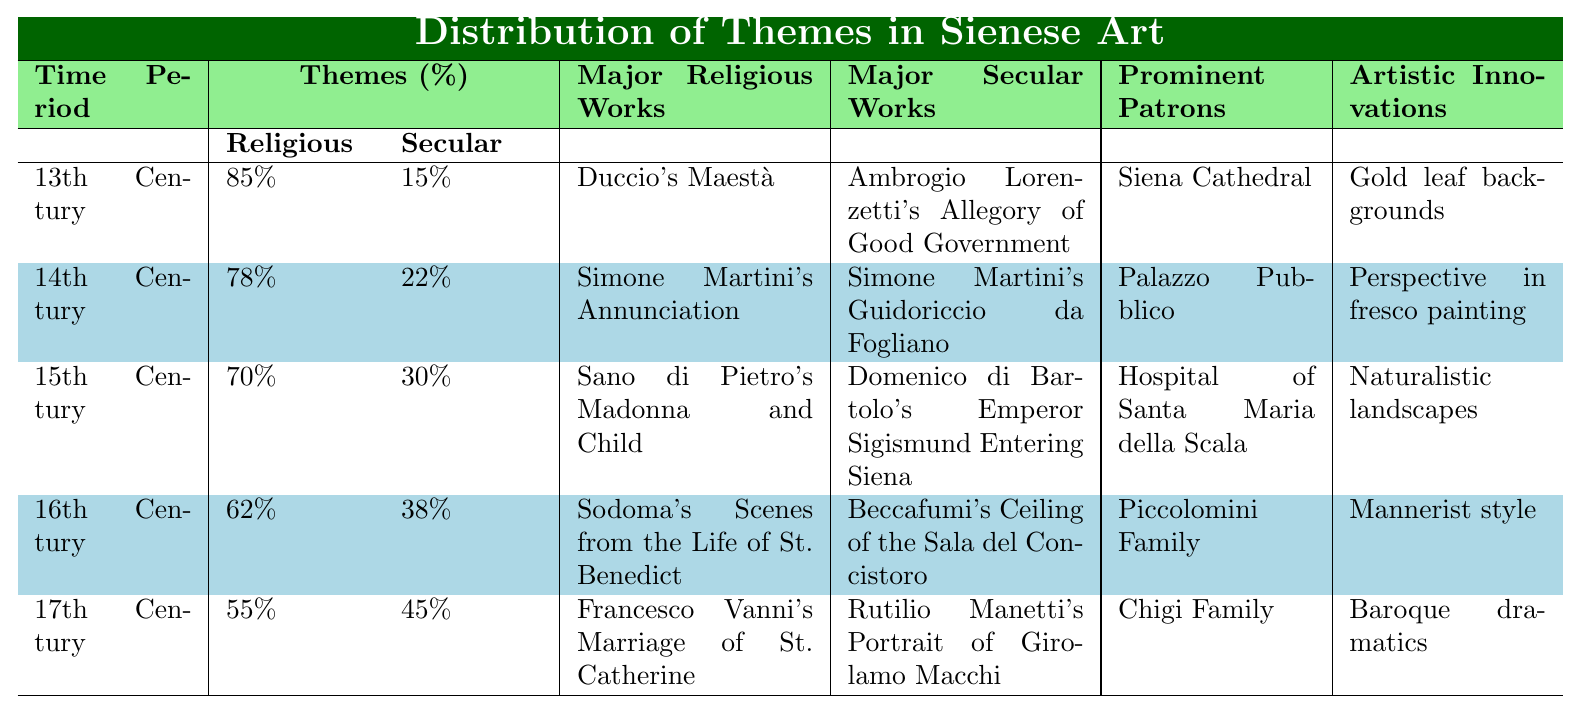What was the percentage of religious themes in the 16th century? The 16th century has a percentage of religious themes listed as 62% in the table.
Answer: 62% Which time period had the highest percentage of secular themes? Upon examining the table, the 17th century shows the highest secular themes percentage at 45%.
Answer: 17th century What major religious work is associated with the 14th century? According to the table, Simone Martini's Annunciation is the major religious work for the 14th century.
Answer: Simone Martini's Annunciation What is the difference in percentage of religious themes between the 13th and 15th centuries? The 13th century has 85% religious themes, and the 15th has 70%. The difference is 85% - 70% = 15%.
Answer: 15% True or False: The percentage of secular themes increased in each subsequent century from the 13th to the 17th century. By reviewing the table, the secular theme percentages are 15%, 22%, 30%, 38%, and 45%, respectively, showing a consistent increase.
Answer: True In which century do we first see less than 60% of religious themes? Looking at the data, the 17th century is the first where religious themes drop below 60%, at 55%.
Answer: 17th century What was the trend in religious themes from the 13th to the 17th century? The trend shows a clear decrease in religious themes: 85% (13th), 78% (14th), 70% (15th), 62% (16th), to 55% (17th), signaling a decline.
Answer: Decrease Which family was a prominent patron during the 17th century? The table indicates that the Chigi Family was the prominent patron in the 17th century.
Answer: Chigi Family What is the average percentage of secular themes across all centuries listed? To find the average: (15% + 22% + 30% + 38% + 45%) = 150%, then divide by 5 resulting in an average of 30%.
Answer: 30% Which major secular work corresponds to the 15th century? The table states that Domenico di Bartolo's Emperor Sigismund Entering Siena is the major secular work of the 15th century.
Answer: Domenico di Bartolo's Emperor Sigismund Entering Siena 